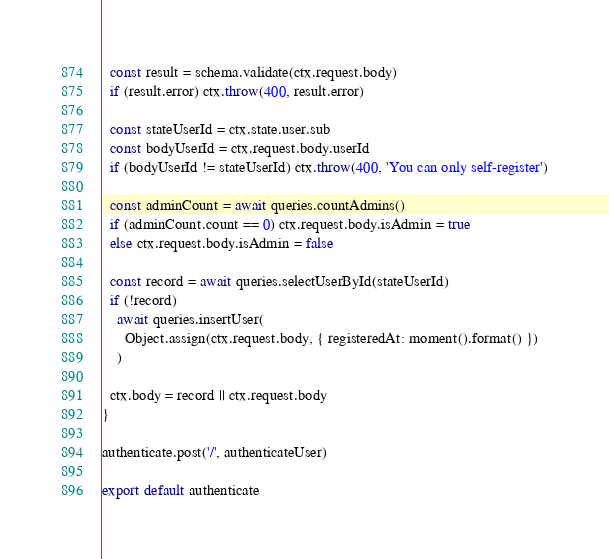Convert code to text. <code><loc_0><loc_0><loc_500><loc_500><_JavaScript_>  const result = schema.validate(ctx.request.body)
  if (result.error) ctx.throw(400, result.error)

  const stateUserId = ctx.state.user.sub
  const bodyUserId = ctx.request.body.userId
  if (bodyUserId != stateUserId) ctx.throw(400, 'You can only self-register')

  const adminCount = await queries.countAdmins()
  if (adminCount.count == 0) ctx.request.body.isAdmin = true
  else ctx.request.body.isAdmin = false

  const record = await queries.selectUserById(stateUserId)
  if (!record)
    await queries.insertUser(
      Object.assign(ctx.request.body, { registeredAt: moment().format() })
    )

  ctx.body = record || ctx.request.body
}

authenticate.post('/', authenticateUser)

export default authenticate
</code> 